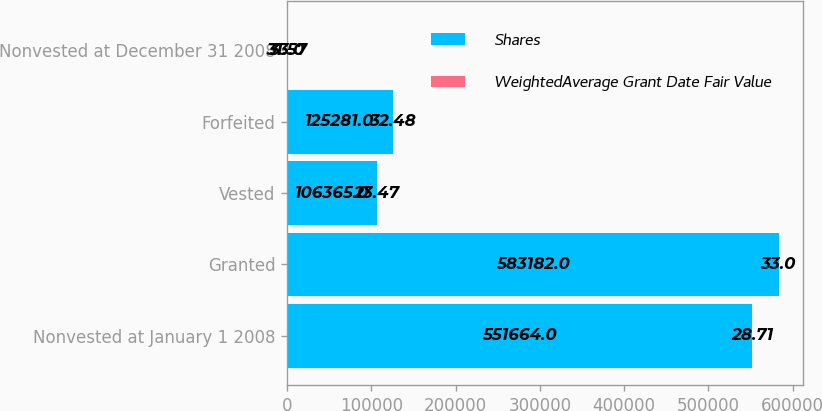Convert chart. <chart><loc_0><loc_0><loc_500><loc_500><stacked_bar_chart><ecel><fcel>Nonvested at January 1 2008<fcel>Granted<fcel>Vested<fcel>Forfeited<fcel>Nonvested at December 31 2008<nl><fcel>Shares<fcel>551664<fcel>583182<fcel>106365<fcel>125281<fcel>33<nl><fcel>WeightedAverage Grant Date Fair Value<fcel>28.71<fcel>33<fcel>23.47<fcel>32.48<fcel>31.57<nl></chart> 